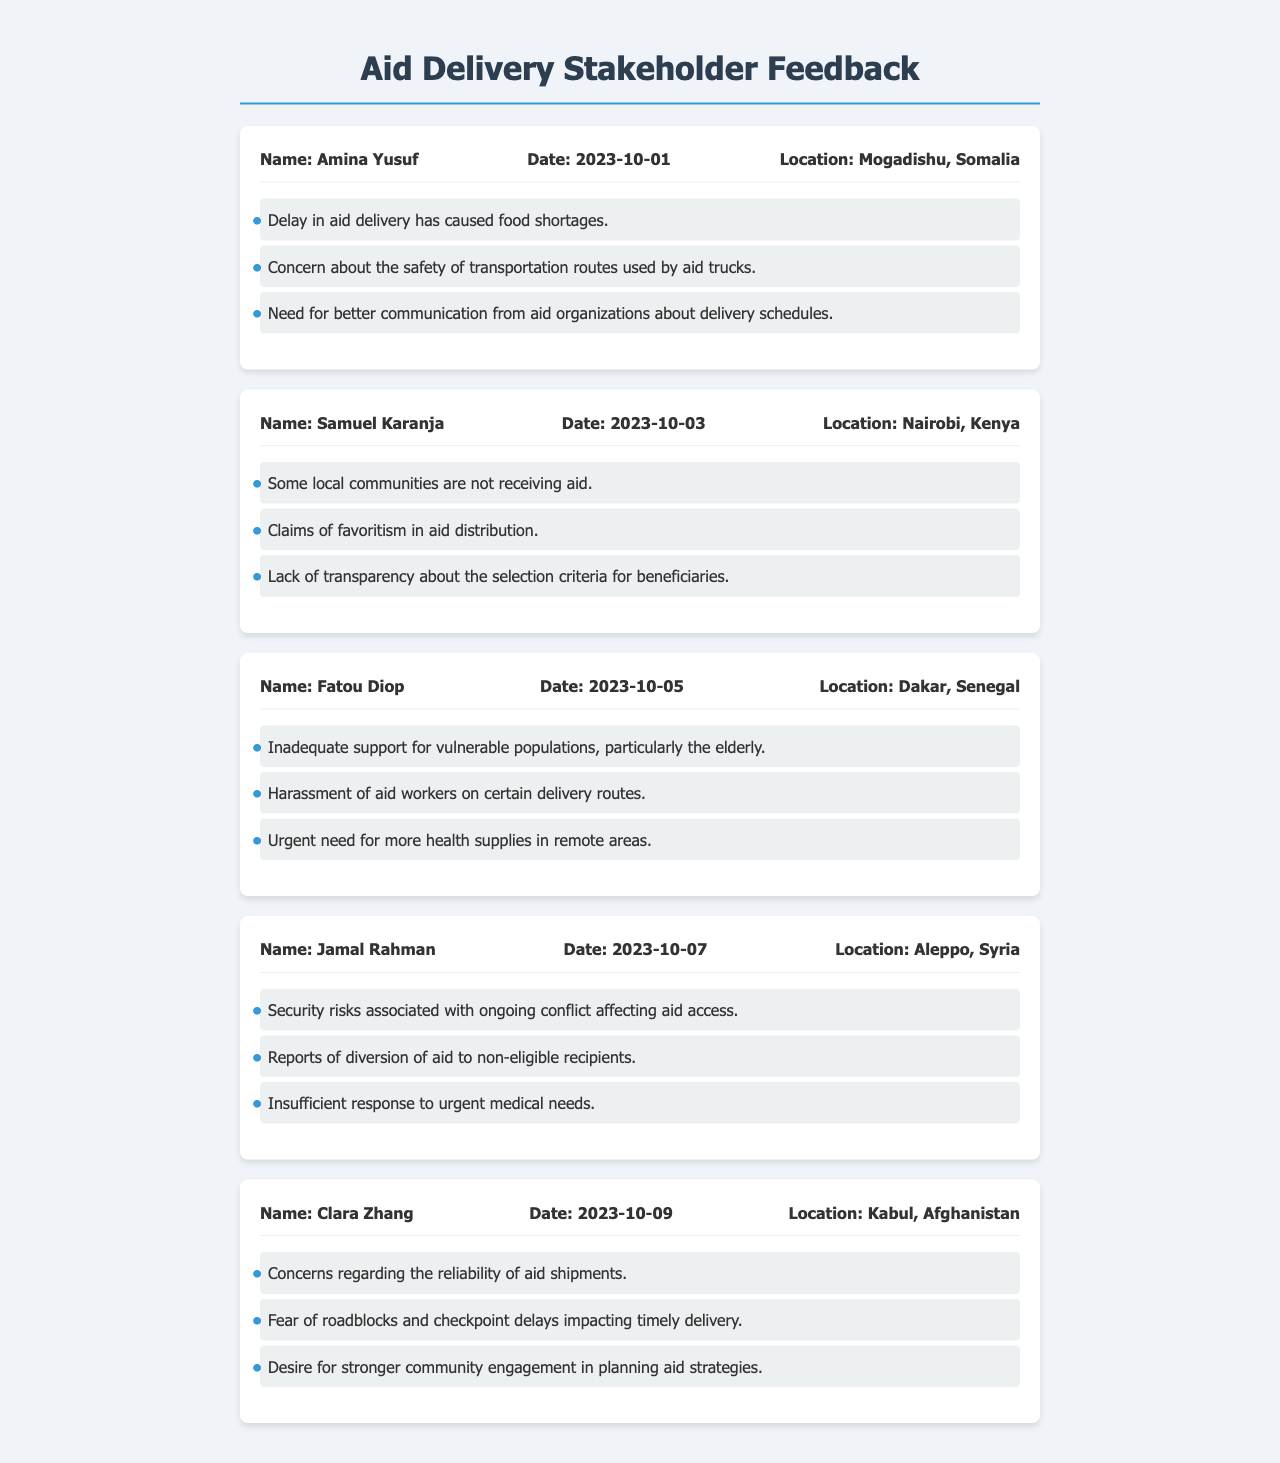What is the name of the individual providing feedback from Mogadishu? The name listed in the feedback from Mogadishu is Amina Yusuf.
Answer: Amina Yusuf On what date did Samuel Karanja provide his feedback? Samuel Karanja's feedback was recorded on October 3, 2023.
Answer: 2023-10-03 What specific issue did Fatou Diop raise regarding the elderly? Fatou Diop mentioned that there was inadequate support for vulnerable populations, particularly the elderly.
Answer: Inadequate support for vulnerable populations, particularly the elderly Which location did Jamal Rahman provide feedback from? Jamal Rahman's feedback comes from Aleppo, Syria.
Answer: Aleppo, Syria What concern regarding aid delivery was raised by Clara Zhang? Clara Zhang expressed concerns about the reliability of aid shipments.
Answer: Reliability of aid shipments Which issue did Amina Yusuf associate with transportation routes? Amina Yusuf raised concerns about the safety of transportation routes used by aid trucks.
Answer: Safety of transportation routes used by aid trucks What is a common theme found in Samuel Karanja's feedback? A common theme in Samuel Karanja's feedback is the claims of favoritism in aid distribution.
Answer: Claims of favoritism in aid distribution What urgent need is identified in Fatou Diop's feedback? Fatou Diop indicated an urgent need for more health supplies in remote areas.
Answer: More health supplies in remote areas How many issues did Jamal Rahman mention in his feedback? Jamal Rahman mentioned three specific issues in his feedback.
Answer: Three 